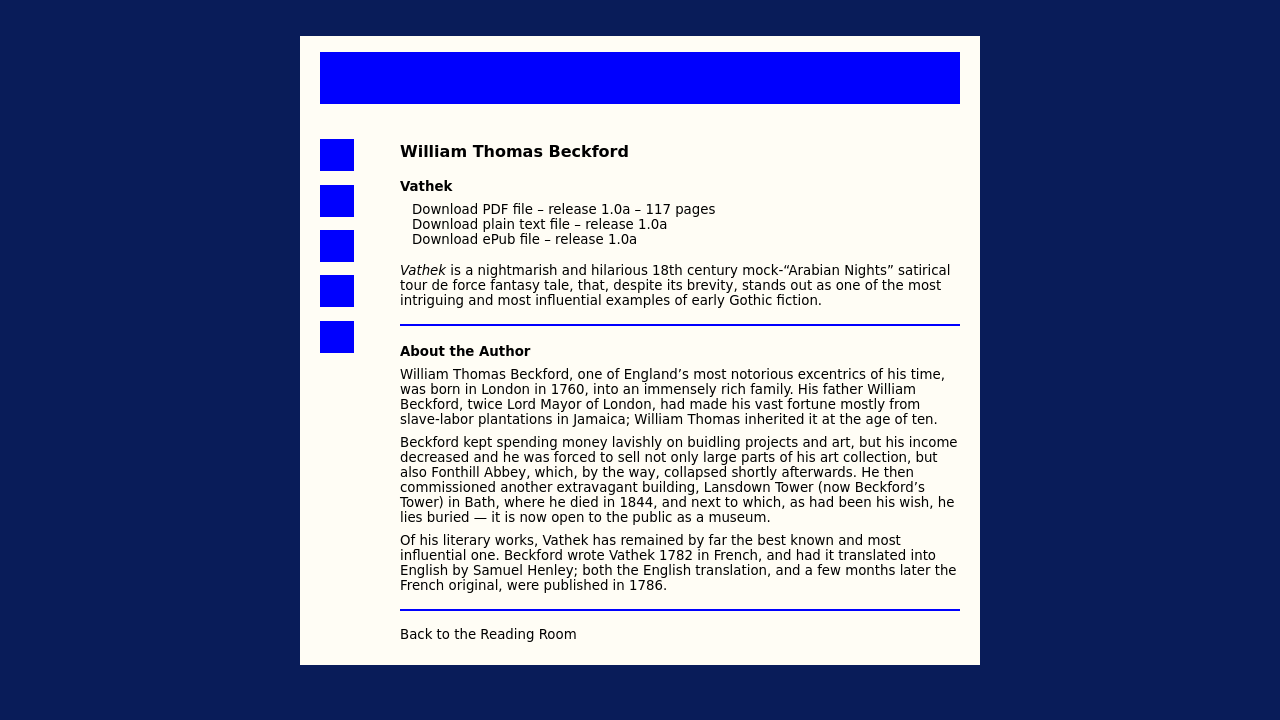What can you tell about the architectural styles in Beckford's buildings such as Fonthill Abbey and Lansdown Tower? William Beckford had a distinct taste for elaborate and grandiose structures. Fonthill Abbey was designed in the Gothic Revival style, which was characterized by its dramatic, romantic, and ornamental elements. Lansdown Tower, also known as Beckford's Tower, reflects a similar neo-Gothic architectural style but on a smaller, more personal scale. How do these architectures reflect his personality or philosophy? Beckford’s architectural endeavors reflect his penchant for the dramatic and the mystical. His buildings express his desire for a retreat from society and his interest in creating personal sanctuaries that mirrored his complex inner world, influenced by his readings and imaginations of Eastern cultures. 